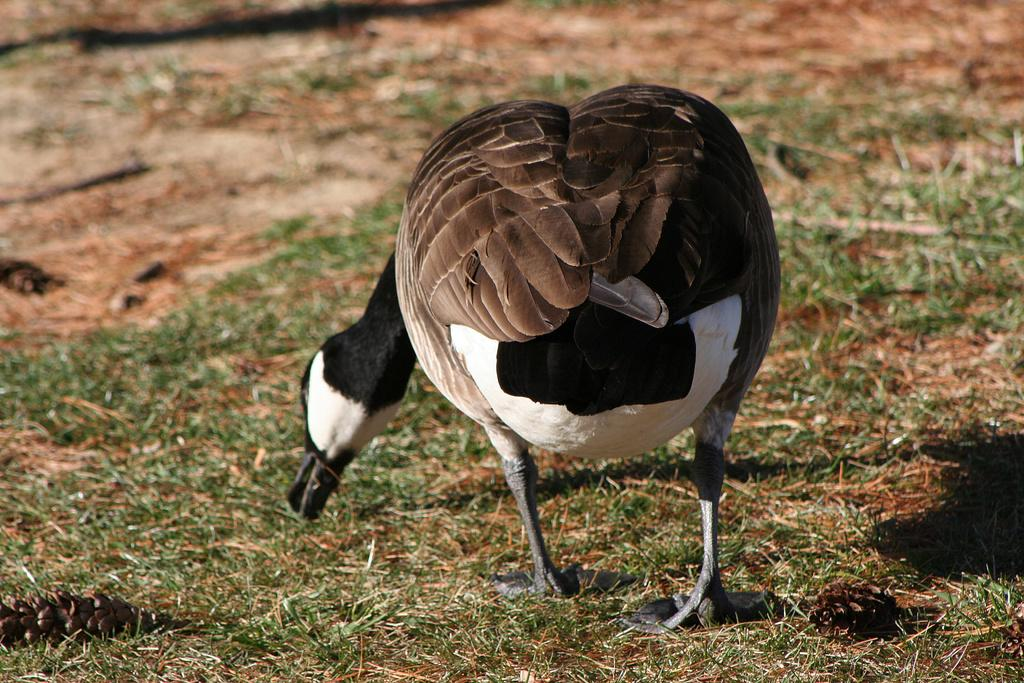What animal is present in the image? There is a goose in the image. What is the goose doing in the image? The goose is eating grass. What type of bread can be seen flying in the image? There is no bread present in the image, and bread cannot fly. 